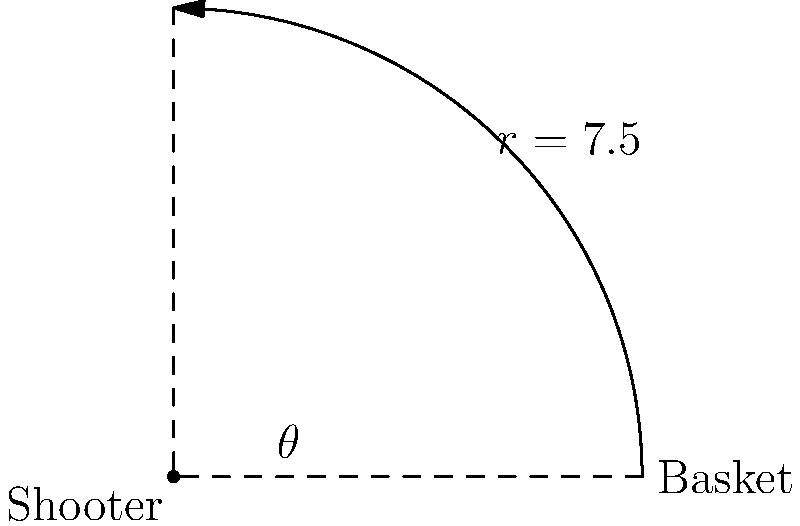As an aspiring basketball player aiming to perfect your three-point shot, you're studying the optimal angle for shooting. In a practice session, you're positioned 7.5 meters from the basket, which is at ground level. Using polar coordinates, where you are at the origin and the basket is on the positive x-axis, what angle $\theta$ (in radians) should you aim for to achieve a 45-degree trajectory for your shot? Let's approach this step-by-step:

1) In polar coordinates, your position (the origin) is represented as $(0,0)$, and the basket is at $(7.5,0)$.

2) The question asks for a 45-degree trajectory, which means the ball should leave your hands at a 45-degree angle to the ground.

3) In polar coordinates, the angle $\theta$ is measured counterclockwise from the positive x-axis. However, the 45-degree trajectory is measured from the ground up.

4) Therefore, the angle we're looking for is the complement of 45 degrees. In other words:

   $\theta = 90° - 45° = 45°$

5) We need to convert this to radians. The formula for converting degrees to radians is:

   $\text{radians} = \frac{\text{degrees} \times \pi}{180°}$

6) Plugging in our value:

   $\theta = \frac{45° \times \pi}{180°} = \frac{\pi}{4}$ radians

Thus, to achieve a 45-degree trajectory, you should aim at an angle of $\frac{\pi}{4}$ radians in the polar coordinate system.
Answer: $\frac{\pi}{4}$ radians 